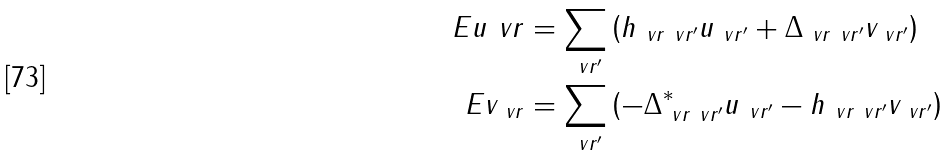Convert formula to latex. <formula><loc_0><loc_0><loc_500><loc_500>E u _ { \ } v r & = \sum _ { \ v r ^ { \prime } } \left ( h _ { \ v r \ v r ^ { \prime } } u _ { \ v r ^ { \prime } } + \Delta _ { \ v r \ v r ^ { \prime } } v _ { \ v r ^ { \prime } } \right ) \\ E v _ { \ v r } & = \sum _ { \ v r ^ { \prime } } \left ( - \Delta ^ { * } _ { \ v r \ v r ^ { \prime } } u _ { \ v r ^ { \prime } } - h _ { \ v r \ v r ^ { \prime } } v _ { \ v r ^ { \prime } } \right )</formula> 